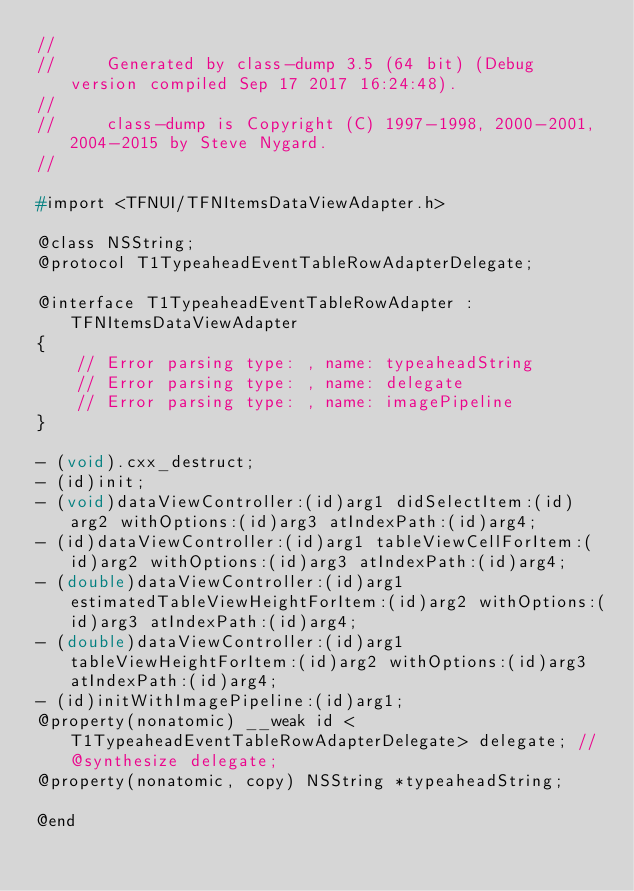Convert code to text. <code><loc_0><loc_0><loc_500><loc_500><_C_>//
//     Generated by class-dump 3.5 (64 bit) (Debug version compiled Sep 17 2017 16:24:48).
//
//     class-dump is Copyright (C) 1997-1998, 2000-2001, 2004-2015 by Steve Nygard.
//

#import <TFNUI/TFNItemsDataViewAdapter.h>

@class NSString;
@protocol T1TypeaheadEventTableRowAdapterDelegate;

@interface T1TypeaheadEventTableRowAdapter : TFNItemsDataViewAdapter
{
    // Error parsing type: , name: typeaheadString
    // Error parsing type: , name: delegate
    // Error parsing type: , name: imagePipeline
}

- (void).cxx_destruct;
- (id)init;
- (void)dataViewController:(id)arg1 didSelectItem:(id)arg2 withOptions:(id)arg3 atIndexPath:(id)arg4;
- (id)dataViewController:(id)arg1 tableViewCellForItem:(id)arg2 withOptions:(id)arg3 atIndexPath:(id)arg4;
- (double)dataViewController:(id)arg1 estimatedTableViewHeightForItem:(id)arg2 withOptions:(id)arg3 atIndexPath:(id)arg4;
- (double)dataViewController:(id)arg1 tableViewHeightForItem:(id)arg2 withOptions:(id)arg3 atIndexPath:(id)arg4;
- (id)initWithImagePipeline:(id)arg1;
@property(nonatomic) __weak id <T1TypeaheadEventTableRowAdapterDelegate> delegate; // @synthesize delegate;
@property(nonatomic, copy) NSString *typeaheadString;

@end

</code> 